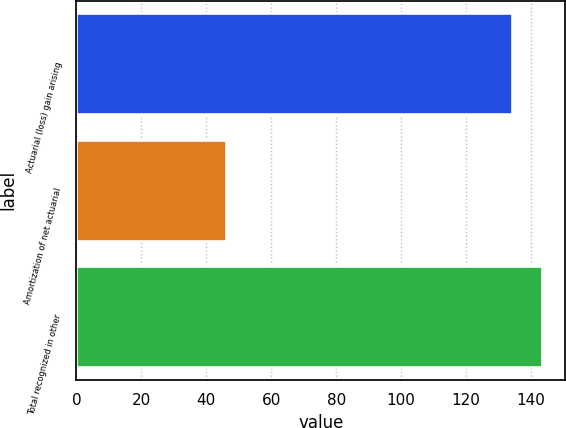Convert chart. <chart><loc_0><loc_0><loc_500><loc_500><bar_chart><fcel>Actuarial (loss) gain arising<fcel>Amortization of net actuarial<fcel>Total recognized in other<nl><fcel>134<fcel>46<fcel>143.3<nl></chart> 